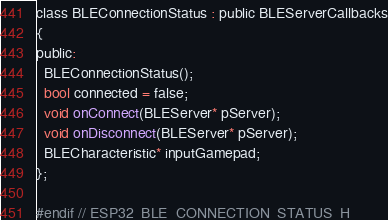<code> <loc_0><loc_0><loc_500><loc_500><_C_>class BLEConnectionStatus : public BLEServerCallbacks
{
public:
  BLEConnectionStatus();
  bool connected = false;
  void onConnect(BLEServer* pServer);
  void onDisconnect(BLEServer* pServer);
  BLECharacteristic* inputGamepad;
};

#endif // ESP32_BLE_CONNECTION_STATUS_H</code> 